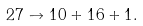Convert formula to latex. <formula><loc_0><loc_0><loc_500><loc_500>2 7 \to 1 0 + 1 6 + 1 .</formula> 